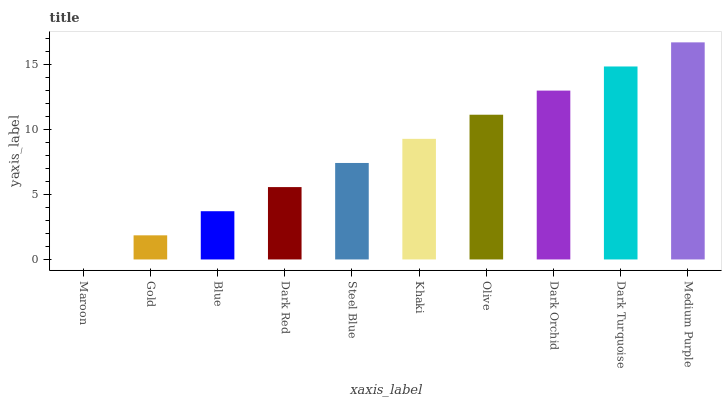Is Gold the minimum?
Answer yes or no. No. Is Gold the maximum?
Answer yes or no. No. Is Gold greater than Maroon?
Answer yes or no. Yes. Is Maroon less than Gold?
Answer yes or no. Yes. Is Maroon greater than Gold?
Answer yes or no. No. Is Gold less than Maroon?
Answer yes or no. No. Is Khaki the high median?
Answer yes or no. Yes. Is Steel Blue the low median?
Answer yes or no. Yes. Is Dark Orchid the high median?
Answer yes or no. No. Is Dark Turquoise the low median?
Answer yes or no. No. 